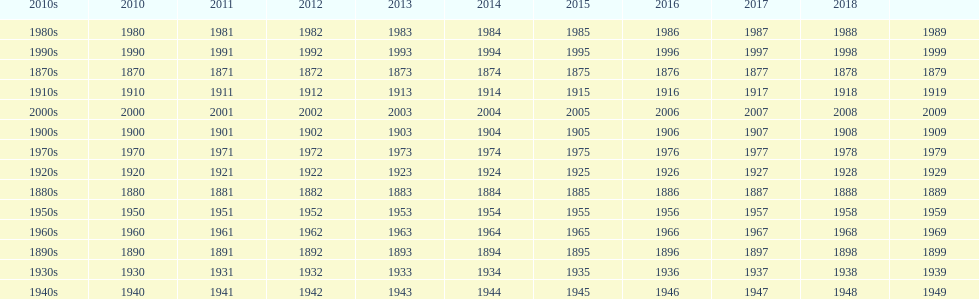What year is after 2018, but does not have a place on the table? 2019. 